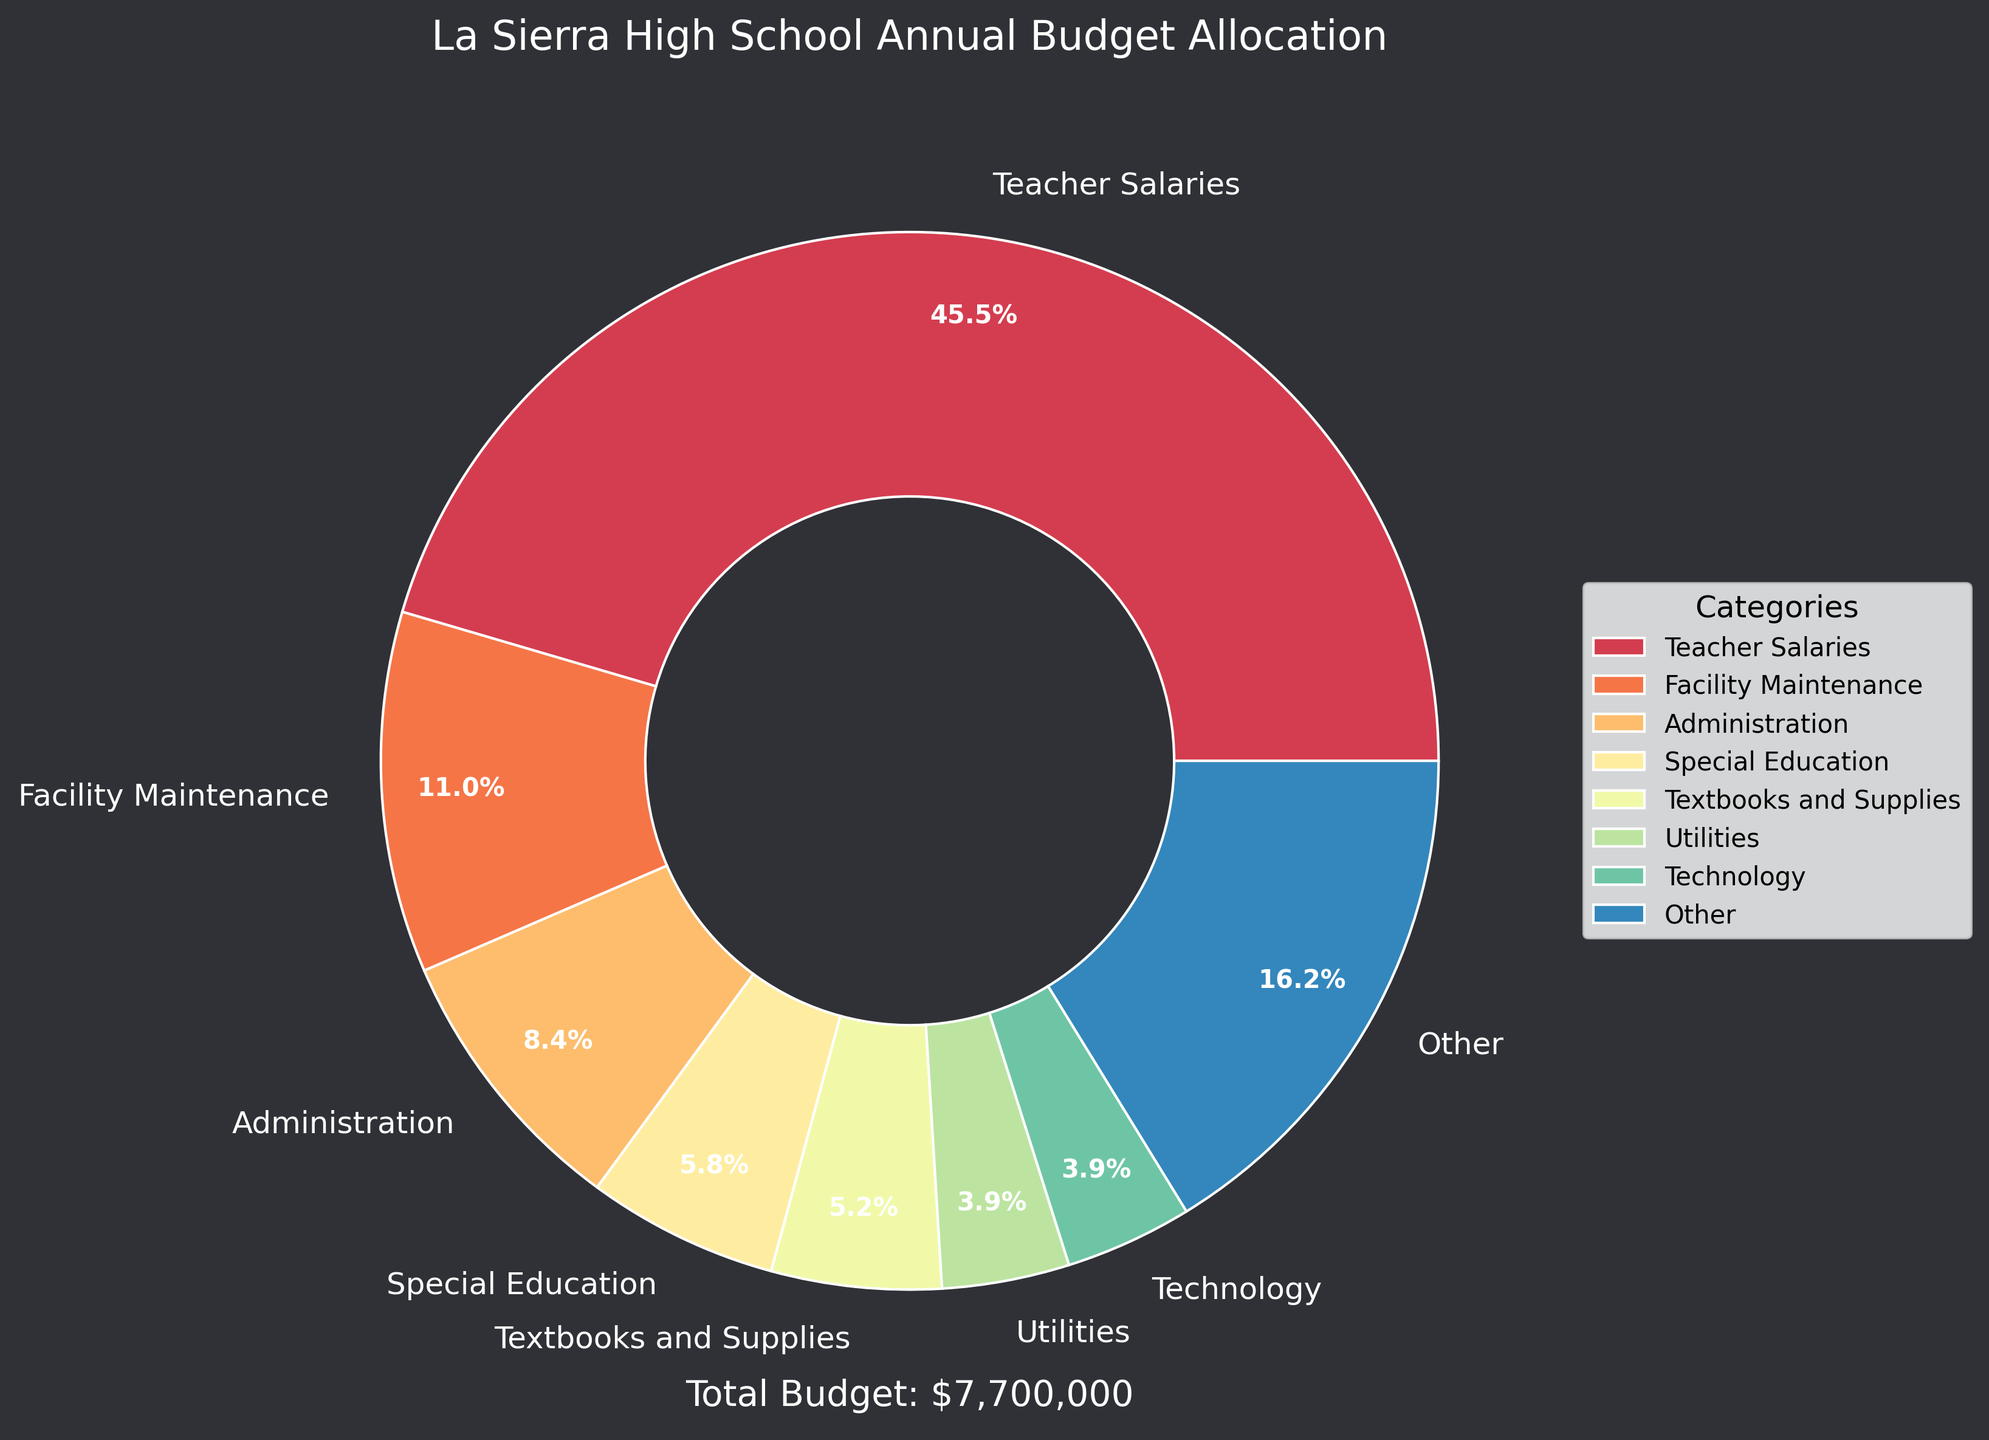what percentage of the budget is allocated to Teacher Salaries? Teacher Salaries is one of the categories listed in the pie chart, and its percentage is represented visually by a slice labeled with that percentage.
Answer: 63.1% Which category gets more funding: Facility Maintenance or Technology? Facility Maintenance has a larger slice visually compared to Technology, indicating a higher percentage. From the pie chart, Facility Maintenance is 15.3%, and Technology is 5.4%.
Answer: Facility Maintenance What portion of the budget goes to categories other than the top 8? In the pie chart, the "Other" category represents the sum of all the smaller categories combined that were not in the top seven allocation categories. This is visible as a single slice labeled with their combined percentage.
Answer: 6.3% If we combine the budget allocations for Food Services and Transportation, what is the percentage of the total budget? From the pie chart, Food Services is 4.0%, and Transportation is 3.2%. When combined, 4.0% + 3.2% = 7.2%.
Answer: 7.2% Is the percentage allocated to Special Education higher than that allocated to Extracurricular Activities by more than 5%? Special Education is shown with 8.1%, and Extracurricular Activities with 3.6%. The difference is 8.1% - 3.6% = 4.5%, which is less than 5%.
Answer: No What is the approximate total amount allocated to Textbooks and Supplies if the total budget is $5,900,000? From the pie chart, Textbooks and Supplies receive 7.2% of the budget. Calculating it: 7.2% of $5,900,000 = 0.072 * $5,900,000 = $424,800.
Answer: $424,800 Comparing Administration and Security, which gets more portion of the budget and by how much? Administration is allocated 11.0%, and Security is allocated 2.5%. The difference is 11.0% - 2.5% = 8.5%.
Answer: Administration by 8.5% What's the combined percentage of the top three categories? The top three categories are Teacher Salaries (63.1%), Facility Maintenance (15.3%), and Special Education (8.1%). Adding these up: 63.1% + 15.3% + 8.1% = 86.5%.
Answer: 86.5% Is Teacher Salaries’ percentage larger than the sum of the bottom five categories shown? The bottom five categories are Library Resources (1.7%), Security (2.5%), Professional Development (2.5%), Transportation (3.2%), and Food Services (4.0%). Adding them: 1.7% + 2.5% + 2.5% + 3.2% + 4.0% = 13.9%. Teacher Salaries are 63.1%, which is larger than 13.9%.
Answer: Yes 